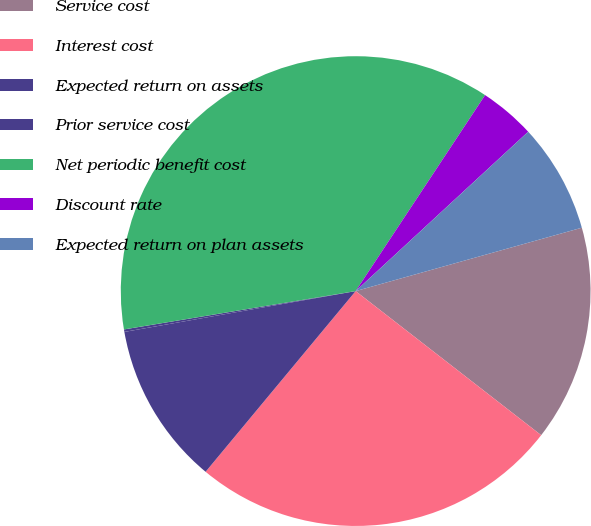Convert chart to OTSL. <chart><loc_0><loc_0><loc_500><loc_500><pie_chart><fcel>Service cost<fcel>Interest cost<fcel>Expected return on assets<fcel>Prior service cost<fcel>Net periodic benefit cost<fcel>Discount rate<fcel>Expected return on plan assets<nl><fcel>14.86%<fcel>25.52%<fcel>11.19%<fcel>0.17%<fcel>36.9%<fcel>3.84%<fcel>7.52%<nl></chart> 